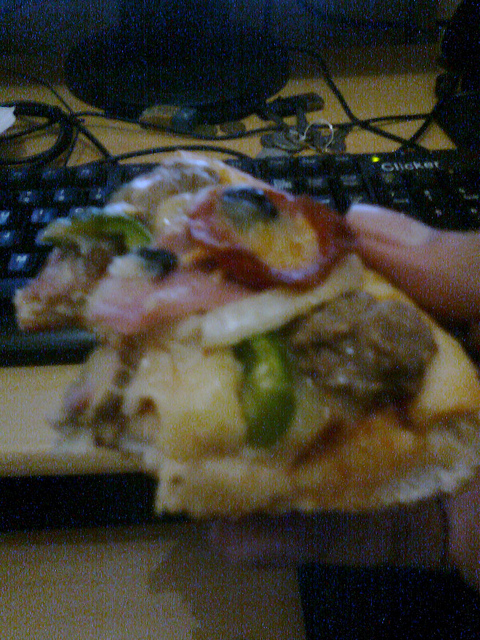What kind of fruit is on the pizza? There are slices of pineapple visible on the pizza. 